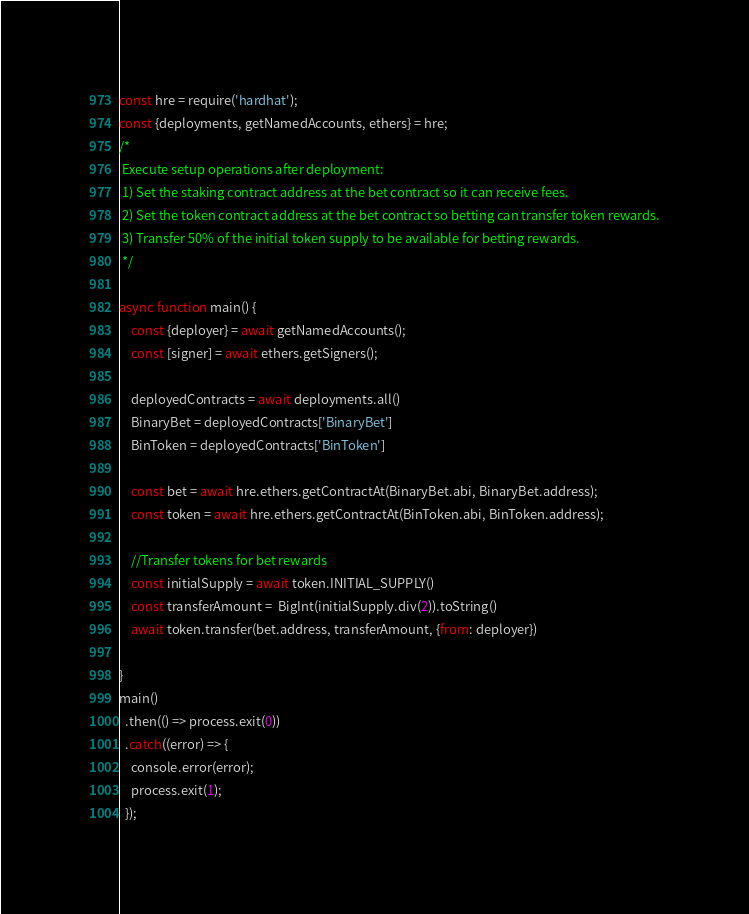Convert code to text. <code><loc_0><loc_0><loc_500><loc_500><_JavaScript_>const hre = require('hardhat');
const {deployments, getNamedAccounts, ethers} = hre;
/*
 Execute setup operations after deployment:
 1) Set the staking contract address at the bet contract so it can receive fees.
 2) Set the token contract address at the bet contract so betting can transfer token rewards.
 3) Transfer 50% of the initial token supply to be available for betting rewards.
 */

async function main() {
    const {deployer} = await getNamedAccounts();
    const [signer] = await ethers.getSigners();

    deployedContracts = await deployments.all()
    BinaryBet = deployedContracts['BinaryBet']
    BinToken = deployedContracts['BinToken']

    const bet = await hre.ethers.getContractAt(BinaryBet.abi, BinaryBet.address);
    const token = await hre.ethers.getContractAt(BinToken.abi, BinToken.address);

    //Transfer tokens for bet rewards
    const initialSupply = await token.INITIAL_SUPPLY()
    const transferAmount =  BigInt(initialSupply.div(2)).toString() 
    await token.transfer(bet.address, transferAmount, {from: deployer})

}
main()
  .then(() => process.exit(0))
  .catch((error) => {
    console.error(error);
    process.exit(1);
  });
</code> 